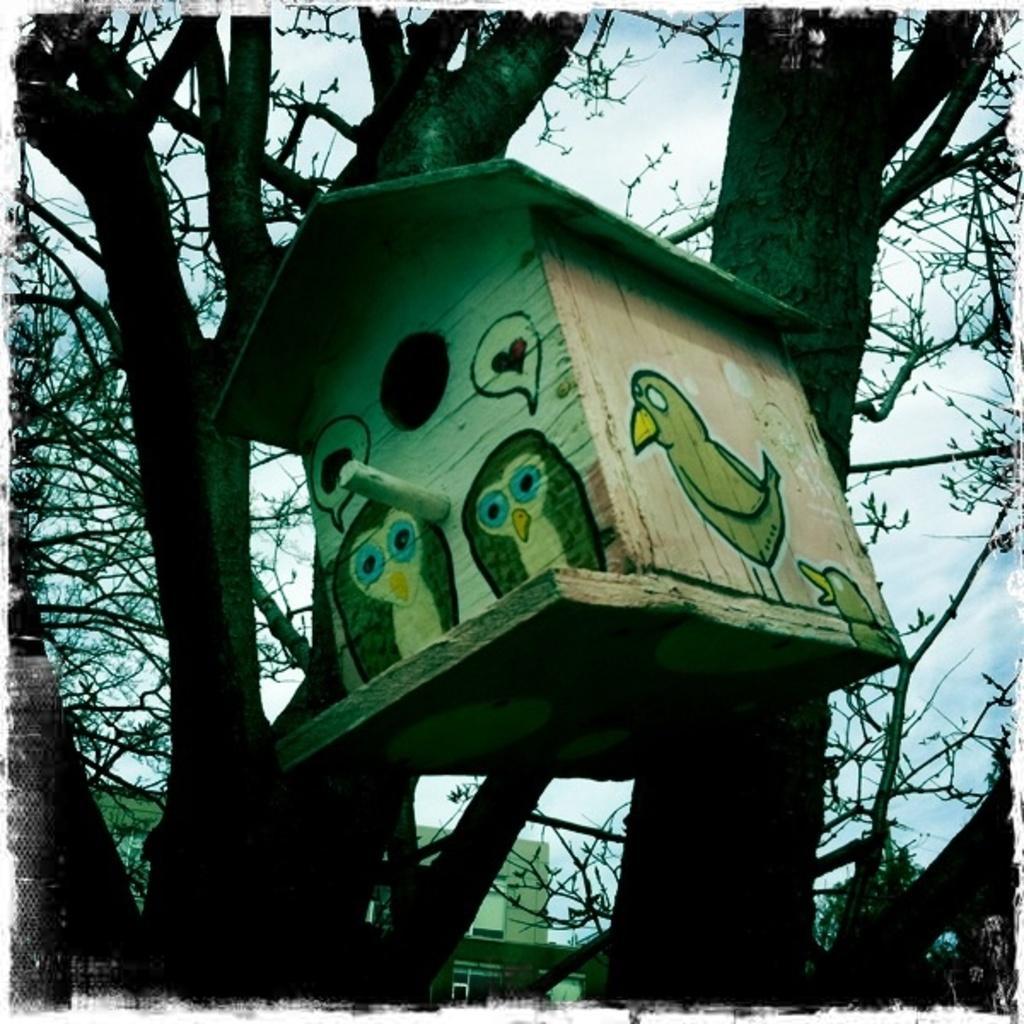Can you describe this image briefly? In the foreground of this image, there is a bird house hanging to a tree. In the background, there is a building and the sky. 